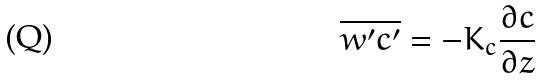<formula> <loc_0><loc_0><loc_500><loc_500>\overline { w ^ { \prime } c ^ { \prime } } = - K _ { c } \frac { \partial c } { \partial z }</formula> 